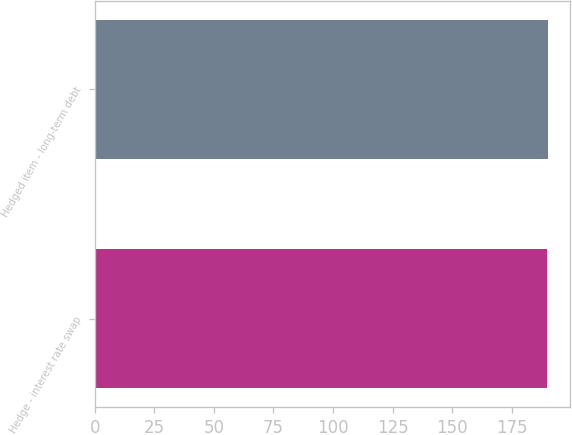<chart> <loc_0><loc_0><loc_500><loc_500><bar_chart><fcel>Hedge - interest rate swap<fcel>Hedged item - long-term debt<nl><fcel>190<fcel>190.1<nl></chart> 